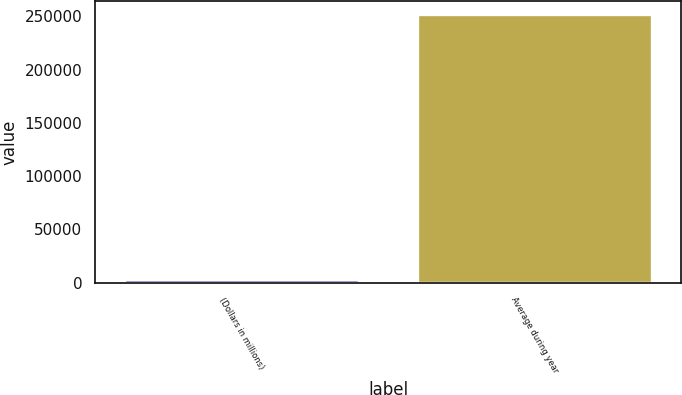Convert chart to OTSL. <chart><loc_0><loc_0><loc_500><loc_500><bar_chart><fcel>(Dollars in millions)<fcel>Average during year<nl><fcel>2018<fcel>251328<nl></chart> 